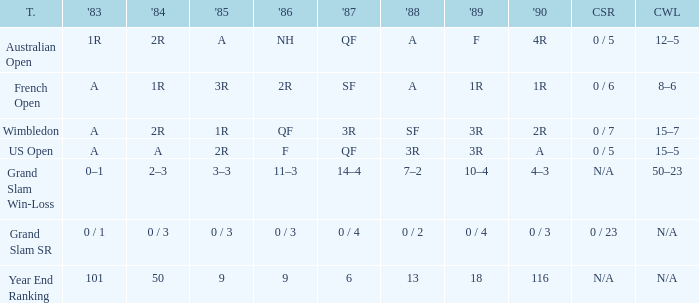What is the 1987 results when the results of 1989 is 3R, and the 1986 results is F? QF. 